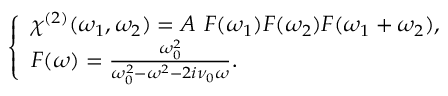<formula> <loc_0><loc_0><loc_500><loc_500>\left \{ \begin{array} { l l } { \chi ^ { ( 2 ) } ( \omega _ { 1 } , \omega _ { 2 } ) = A \ F ( \omega _ { 1 } ) F ( \omega _ { 2 } ) F ( \omega _ { 1 } + \omega _ { 2 } ) , } \\ { F ( \omega ) = \frac { \omega _ { 0 } ^ { 2 } } { \omega _ { 0 } ^ { 2 } - \omega ^ { 2 } - 2 i \nu _ { 0 } \omega } . } \end{array}</formula> 